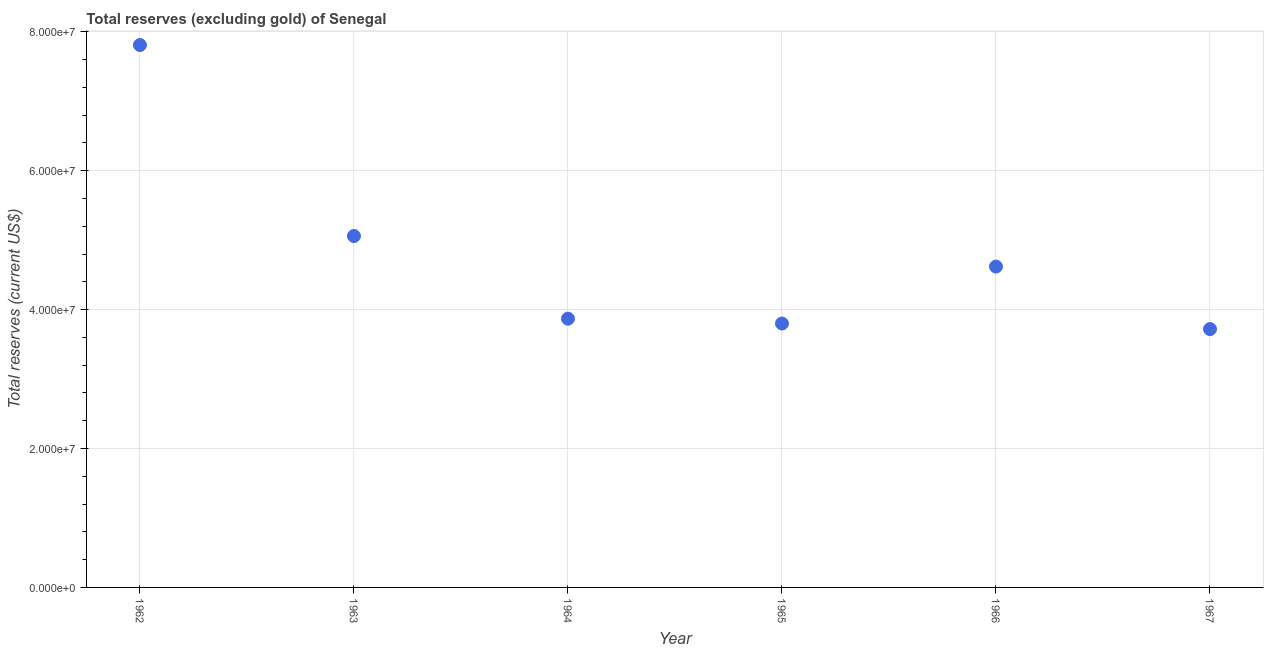What is the total reserves (excluding gold) in 1963?
Make the answer very short. 5.06e+07. Across all years, what is the maximum total reserves (excluding gold)?
Your answer should be compact. 7.81e+07. Across all years, what is the minimum total reserves (excluding gold)?
Your response must be concise. 3.72e+07. In which year was the total reserves (excluding gold) maximum?
Provide a succinct answer. 1962. In which year was the total reserves (excluding gold) minimum?
Keep it short and to the point. 1967. What is the sum of the total reserves (excluding gold)?
Ensure brevity in your answer.  2.89e+08. What is the difference between the total reserves (excluding gold) in 1962 and 1966?
Your response must be concise. 3.19e+07. What is the average total reserves (excluding gold) per year?
Offer a terse response. 4.81e+07. What is the median total reserves (excluding gold)?
Keep it short and to the point. 4.24e+07. Do a majority of the years between 1964 and 1966 (inclusive) have total reserves (excluding gold) greater than 28000000 US$?
Your answer should be very brief. Yes. What is the ratio of the total reserves (excluding gold) in 1962 to that in 1965?
Your answer should be compact. 2.06. Is the total reserves (excluding gold) in 1963 less than that in 1967?
Offer a terse response. No. What is the difference between the highest and the second highest total reserves (excluding gold)?
Your answer should be very brief. 2.75e+07. Is the sum of the total reserves (excluding gold) in 1964 and 1966 greater than the maximum total reserves (excluding gold) across all years?
Offer a terse response. Yes. What is the difference between the highest and the lowest total reserves (excluding gold)?
Provide a short and direct response. 4.09e+07. In how many years, is the total reserves (excluding gold) greater than the average total reserves (excluding gold) taken over all years?
Provide a short and direct response. 2. Does the total reserves (excluding gold) monotonically increase over the years?
Make the answer very short. No. What is the difference between two consecutive major ticks on the Y-axis?
Your answer should be very brief. 2.00e+07. Are the values on the major ticks of Y-axis written in scientific E-notation?
Offer a terse response. Yes. What is the title of the graph?
Your response must be concise. Total reserves (excluding gold) of Senegal. What is the label or title of the Y-axis?
Offer a terse response. Total reserves (current US$). What is the Total reserves (current US$) in 1962?
Offer a very short reply. 7.81e+07. What is the Total reserves (current US$) in 1963?
Offer a very short reply. 5.06e+07. What is the Total reserves (current US$) in 1964?
Your response must be concise. 3.87e+07. What is the Total reserves (current US$) in 1965?
Give a very brief answer. 3.80e+07. What is the Total reserves (current US$) in 1966?
Ensure brevity in your answer.  4.62e+07. What is the Total reserves (current US$) in 1967?
Your answer should be compact. 3.72e+07. What is the difference between the Total reserves (current US$) in 1962 and 1963?
Your response must be concise. 2.75e+07. What is the difference between the Total reserves (current US$) in 1962 and 1964?
Ensure brevity in your answer.  3.94e+07. What is the difference between the Total reserves (current US$) in 1962 and 1965?
Your response must be concise. 4.01e+07. What is the difference between the Total reserves (current US$) in 1962 and 1966?
Give a very brief answer. 3.19e+07. What is the difference between the Total reserves (current US$) in 1962 and 1967?
Provide a succinct answer. 4.09e+07. What is the difference between the Total reserves (current US$) in 1963 and 1964?
Provide a short and direct response. 1.19e+07. What is the difference between the Total reserves (current US$) in 1963 and 1965?
Make the answer very short. 1.26e+07. What is the difference between the Total reserves (current US$) in 1963 and 1966?
Provide a succinct answer. 4.40e+06. What is the difference between the Total reserves (current US$) in 1963 and 1967?
Provide a succinct answer. 1.34e+07. What is the difference between the Total reserves (current US$) in 1964 and 1965?
Your answer should be very brief. 7.00e+05. What is the difference between the Total reserves (current US$) in 1964 and 1966?
Your response must be concise. -7.50e+06. What is the difference between the Total reserves (current US$) in 1964 and 1967?
Provide a short and direct response. 1.50e+06. What is the difference between the Total reserves (current US$) in 1965 and 1966?
Your answer should be very brief. -8.20e+06. What is the difference between the Total reserves (current US$) in 1965 and 1967?
Give a very brief answer. 8.00e+05. What is the difference between the Total reserves (current US$) in 1966 and 1967?
Give a very brief answer. 9.00e+06. What is the ratio of the Total reserves (current US$) in 1962 to that in 1963?
Your response must be concise. 1.54. What is the ratio of the Total reserves (current US$) in 1962 to that in 1964?
Offer a terse response. 2.02. What is the ratio of the Total reserves (current US$) in 1962 to that in 1965?
Offer a very short reply. 2.06. What is the ratio of the Total reserves (current US$) in 1962 to that in 1966?
Provide a short and direct response. 1.69. What is the ratio of the Total reserves (current US$) in 1962 to that in 1967?
Give a very brief answer. 2.1. What is the ratio of the Total reserves (current US$) in 1963 to that in 1964?
Offer a terse response. 1.31. What is the ratio of the Total reserves (current US$) in 1963 to that in 1965?
Give a very brief answer. 1.33. What is the ratio of the Total reserves (current US$) in 1963 to that in 1966?
Keep it short and to the point. 1.09. What is the ratio of the Total reserves (current US$) in 1963 to that in 1967?
Your response must be concise. 1.36. What is the ratio of the Total reserves (current US$) in 1964 to that in 1965?
Your response must be concise. 1.02. What is the ratio of the Total reserves (current US$) in 1964 to that in 1966?
Give a very brief answer. 0.84. What is the ratio of the Total reserves (current US$) in 1965 to that in 1966?
Provide a short and direct response. 0.82. What is the ratio of the Total reserves (current US$) in 1965 to that in 1967?
Offer a terse response. 1.02. What is the ratio of the Total reserves (current US$) in 1966 to that in 1967?
Keep it short and to the point. 1.24. 